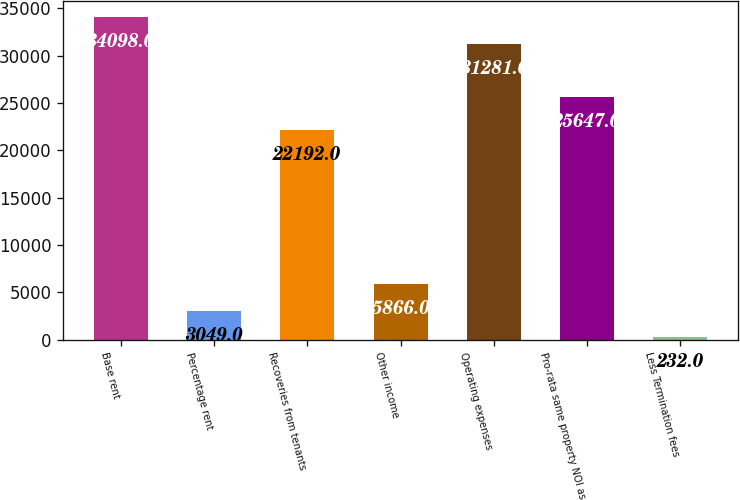Convert chart to OTSL. <chart><loc_0><loc_0><loc_500><loc_500><bar_chart><fcel>Base rent<fcel>Percentage rent<fcel>Recoveries from tenants<fcel>Other income<fcel>Operating expenses<fcel>Pro-rata same property NOI as<fcel>Less Termination fees<nl><fcel>34098<fcel>3049<fcel>22192<fcel>5866<fcel>31281<fcel>25647<fcel>232<nl></chart> 